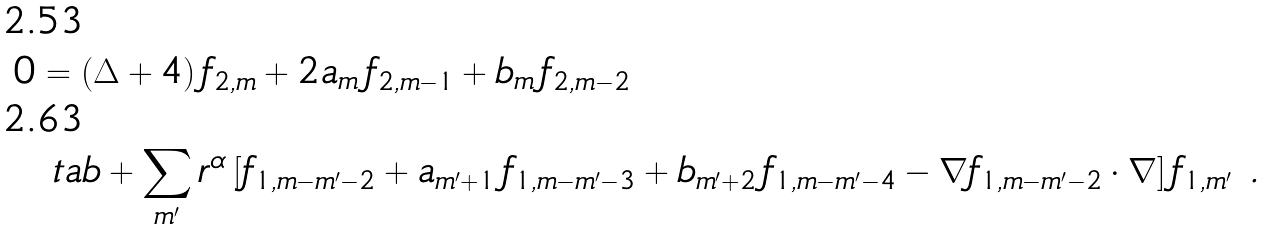<formula> <loc_0><loc_0><loc_500><loc_500>0 & = ( \Delta + 4 ) \, f _ { 2 , m } + 2 a _ { m } \, f _ { 2 , m - 1 } + b _ { m } \, f _ { 2 , m - 2 } \\ & \ t a b + \sum _ { m ^ { \prime } } r ^ { \alpha } \left [ f _ { 1 , m - m ^ { \prime } - 2 } + a _ { m ^ { \prime } + 1 } \, f _ { 1 , m - m ^ { \prime } - 3 } + b _ { m ^ { \prime } + 2 } \, f _ { 1 , m - m ^ { \prime } - 4 } - \nabla f _ { 1 , m - m ^ { \prime } - 2 } \cdot \nabla \right ] f _ { 1 , m ^ { \prime } } \ .</formula> 